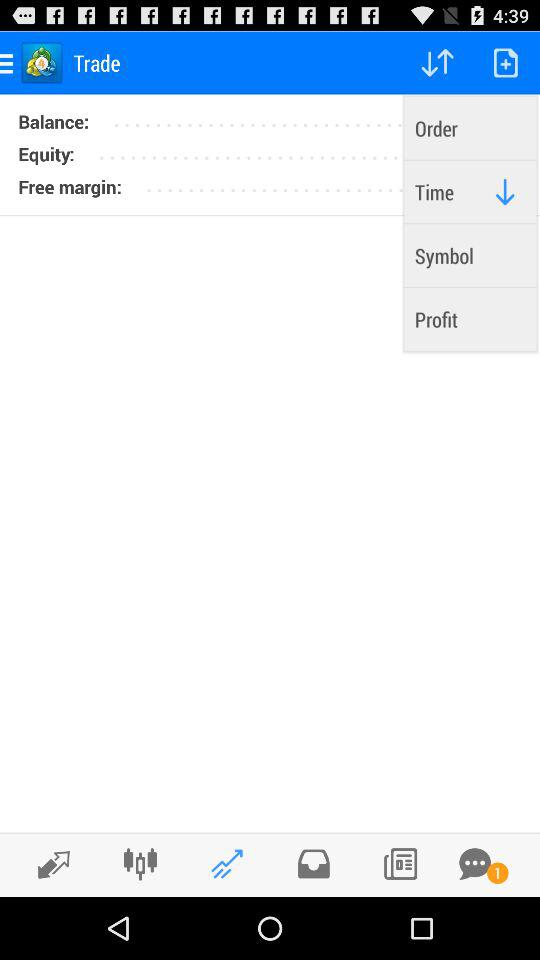How many unread messages are there? There is 1 unread message. 